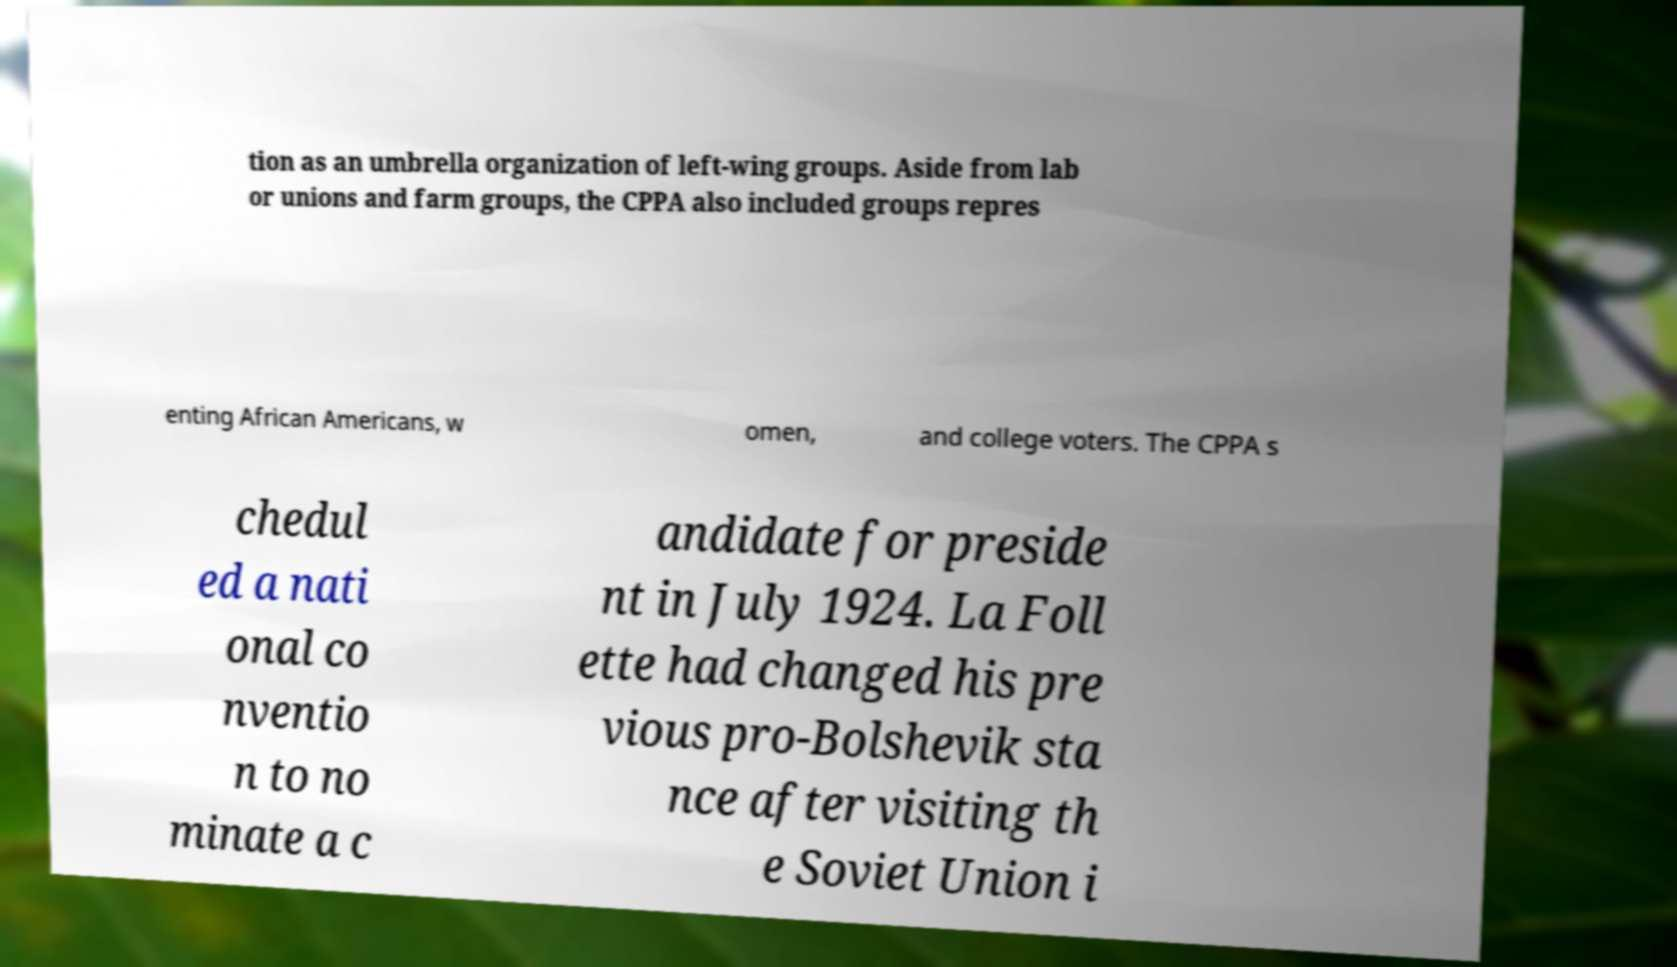Could you assist in decoding the text presented in this image and type it out clearly? tion as an umbrella organization of left-wing groups. Aside from lab or unions and farm groups, the CPPA also included groups repres enting African Americans, w omen, and college voters. The CPPA s chedul ed a nati onal co nventio n to no minate a c andidate for preside nt in July 1924. La Foll ette had changed his pre vious pro-Bolshevik sta nce after visiting th e Soviet Union i 